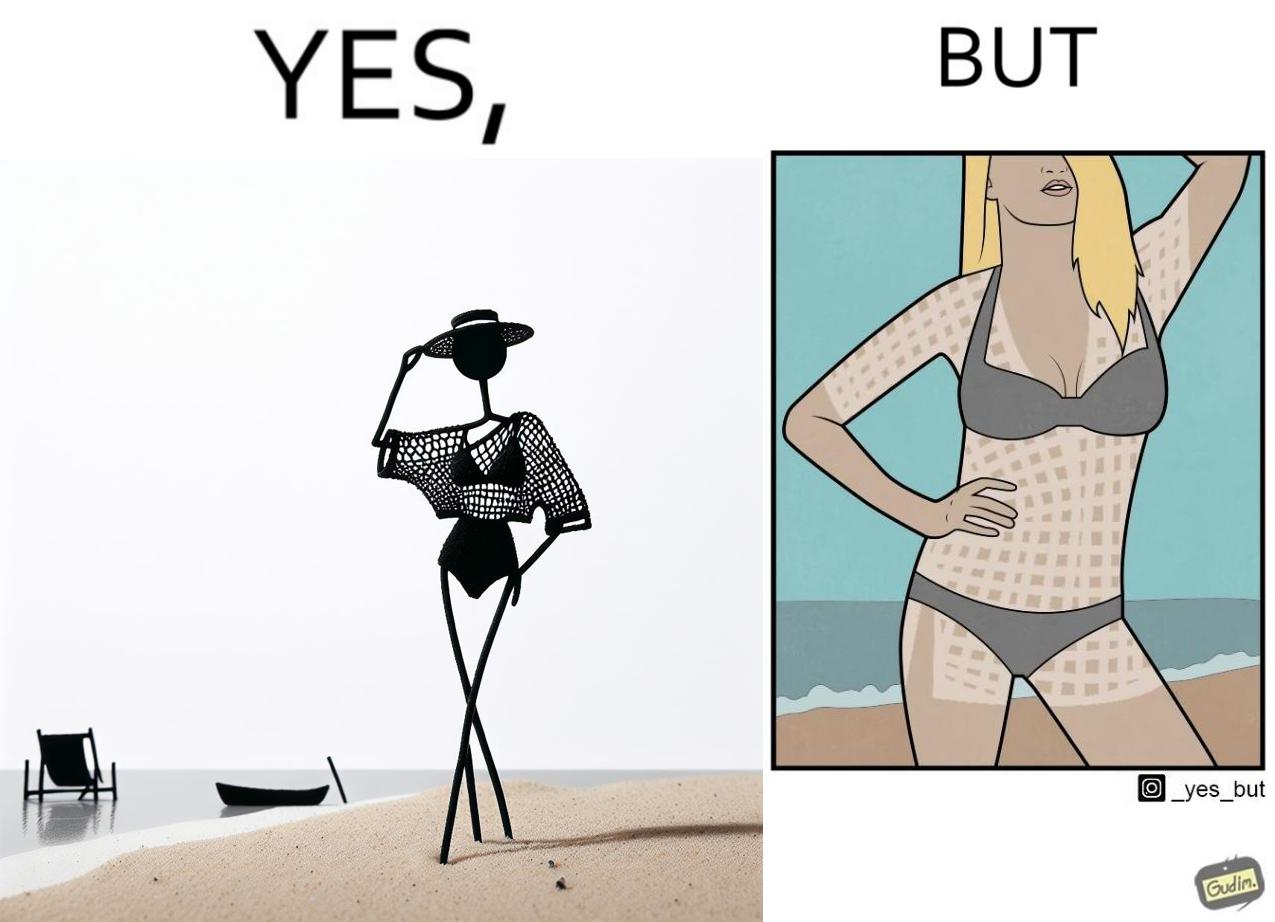Describe what you see in this image. Women wear netted tops while out in the sun on the beach as a beachwear, but when the person removes it, the skin is tanned in the same netted pattern looks weird, and goes against the purpose of using it as beachwear 